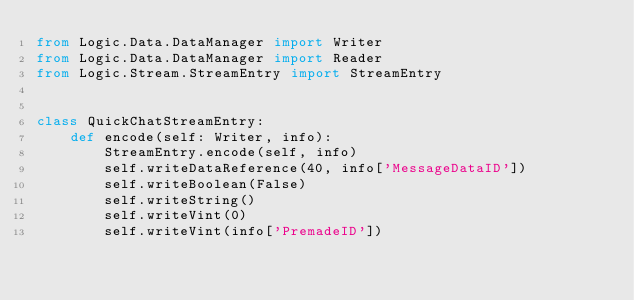<code> <loc_0><loc_0><loc_500><loc_500><_Python_>from Logic.Data.DataManager import Writer
from Logic.Data.DataManager import Reader
from Logic.Stream.StreamEntry import StreamEntry


class QuickChatStreamEntry:
    def encode(self: Writer, info):
        StreamEntry.encode(self, info)
        self.writeDataReference(40, info['MessageDataID'])
        self.writeBoolean(False)
        self.writeString()
        self.writeVint(0)
        self.writeVint(info['PremadeID'])</code> 